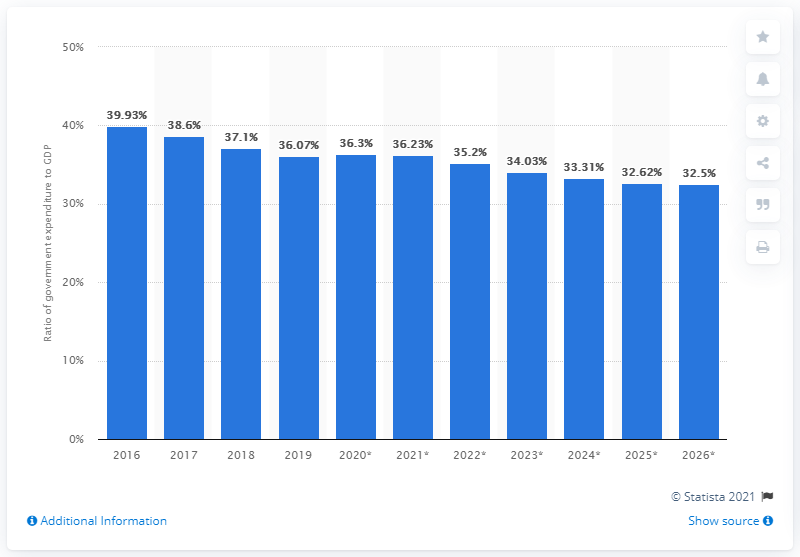Give some essential details in this illustration. In 2019, government expenditure accounted for approximately 36.23% of Bolivia's Gross Domestic Product (GDP). 